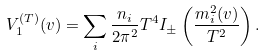Convert formula to latex. <formula><loc_0><loc_0><loc_500><loc_500>V _ { 1 } ^ { ( T ) } ( v ) = \sum _ { i } \frac { n _ { i } } { 2 \pi ^ { 2 } } T ^ { 4 } I _ { \pm } \left ( \frac { m _ { i } ^ { 2 } ( v ) } { T ^ { 2 } } \right ) .</formula> 